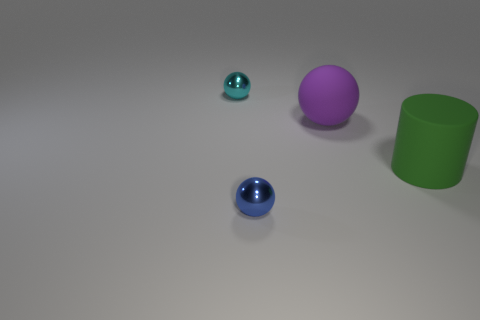There is a thing that is behind the big green thing and right of the cyan sphere; what material is it?
Give a very brief answer. Rubber. Does the metallic sphere that is in front of the large green matte thing have the same color as the small ball that is behind the large cylinder?
Offer a terse response. No. How many other objects are there of the same size as the purple rubber ball?
Offer a terse response. 1. Are there any purple balls that are behind the metal ball that is left of the metal thing in front of the big purple rubber ball?
Provide a succinct answer. No. Is the material of the small sphere that is to the right of the cyan metal object the same as the cylinder?
Provide a short and direct response. No. The other tiny object that is the same shape as the small cyan metal object is what color?
Provide a succinct answer. Blue. Is there any other thing that is the same shape as the tiny blue object?
Offer a terse response. Yes. Is the number of spheres that are in front of the tiny cyan sphere the same as the number of cyan metallic balls?
Ensure brevity in your answer.  No. Are there any large things in front of the cyan sphere?
Keep it short and to the point. Yes. What size is the metallic ball that is to the right of the small sphere that is behind the big object that is right of the big purple matte ball?
Give a very brief answer. Small. 